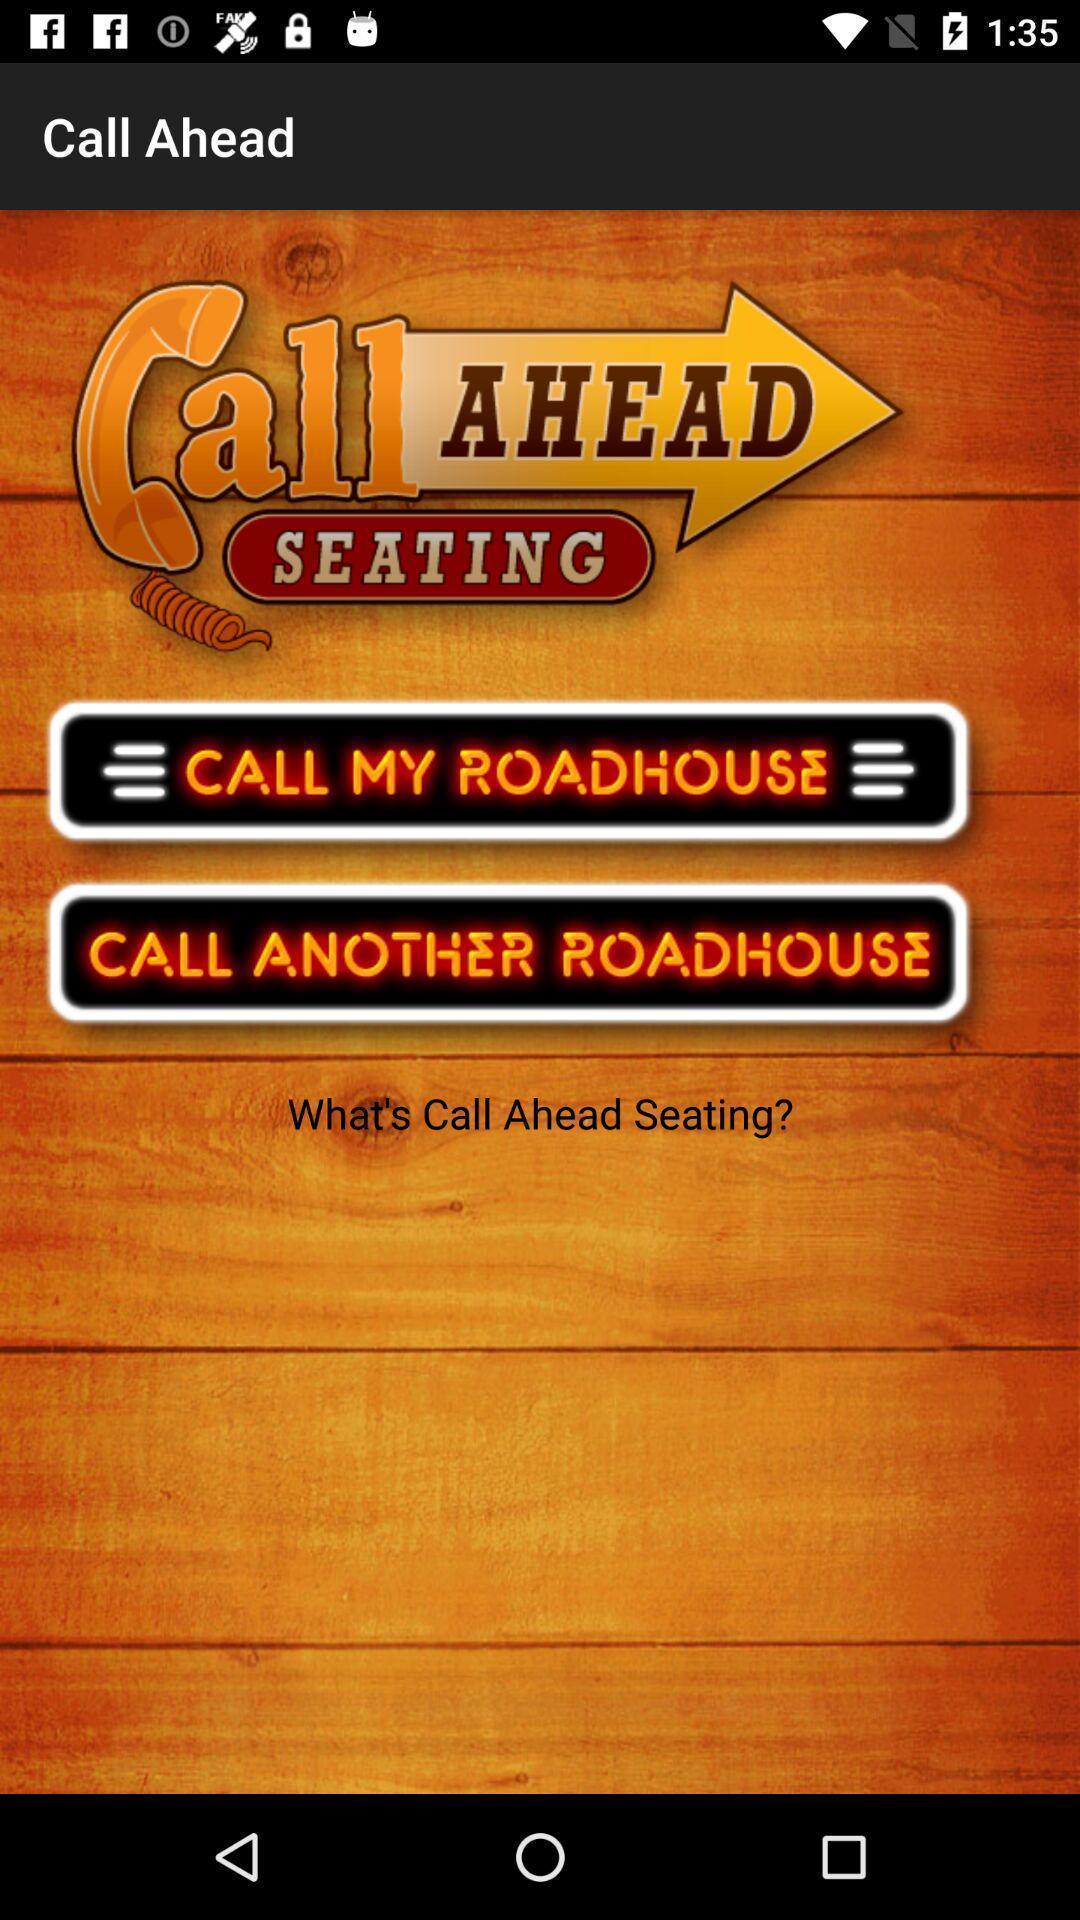Explain the elements present in this screenshot. Window displaying a call page. 